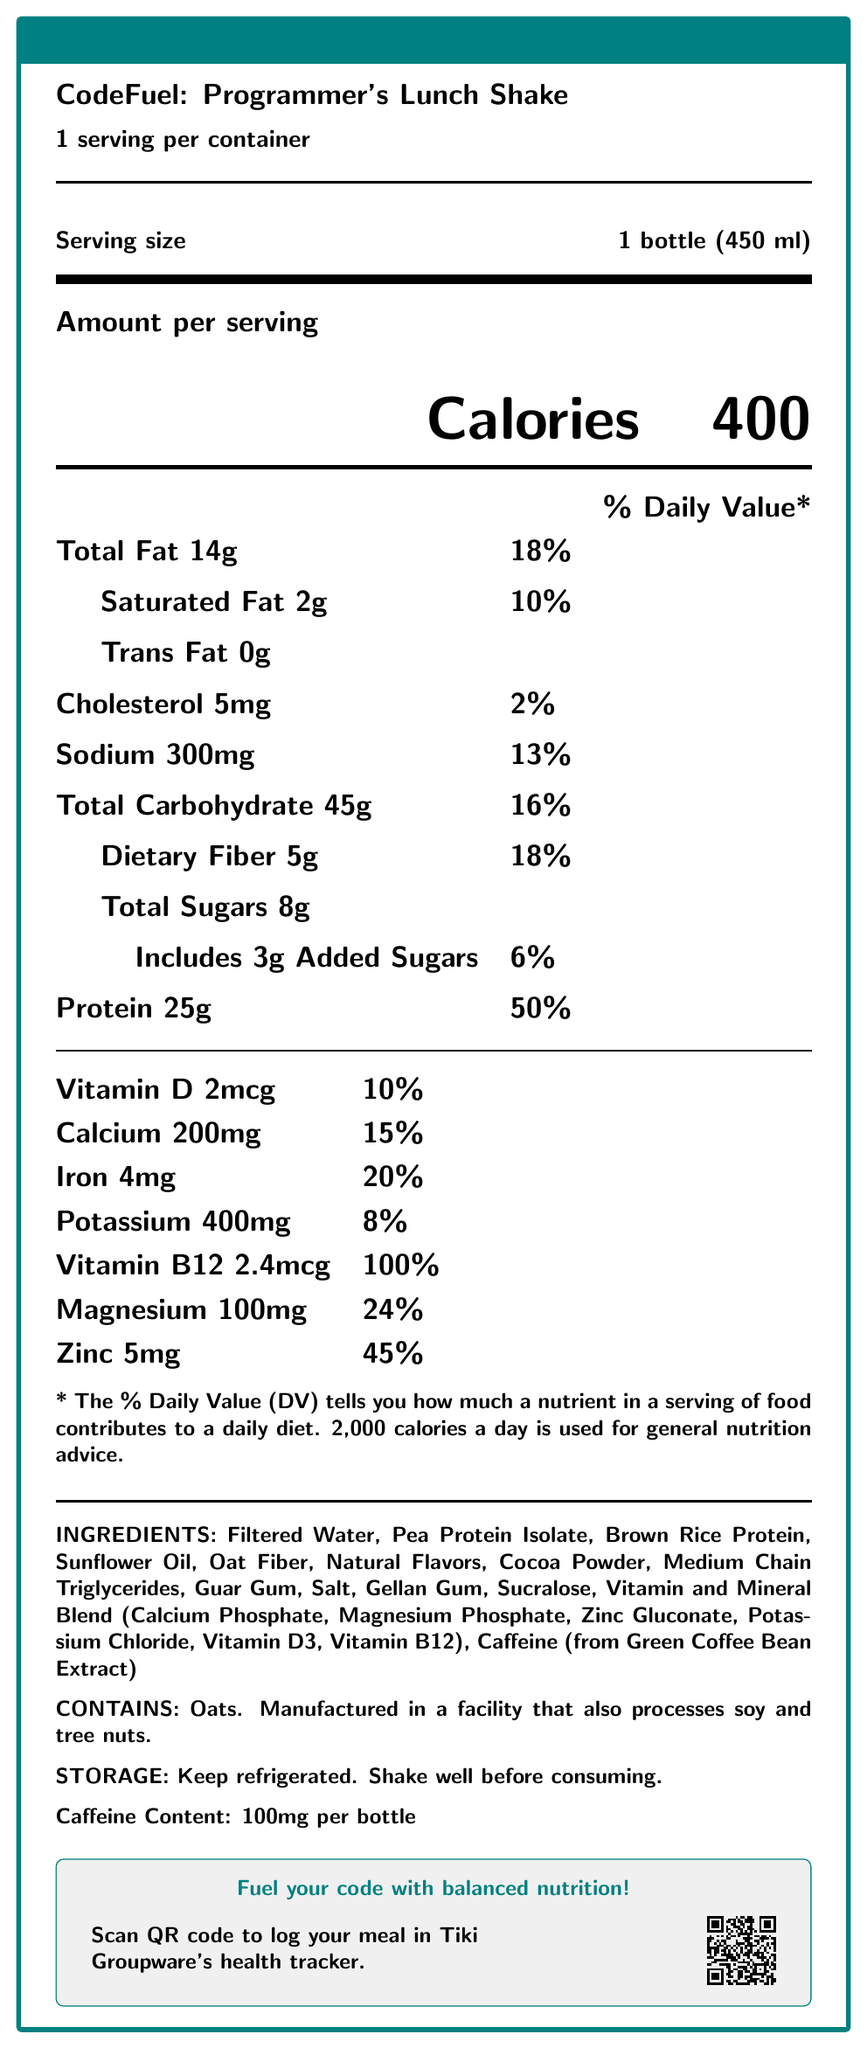what is the serving size for CodeFuel: Programmer's Lunch Shake? The document specifies the serving size as "1 bottle (450 ml)".
Answer: 1 bottle (450 ml) how many calories are in one serving of this shake? The document states that the shake has 400 calories per serving.
Answer: 400 what is the total amount of protein in this shake? The document mentions that the shake contains 25g of protein per serving.
Answer: 25g what are the primary sources of protein listed in the ingredients? The ingredients section lists "Pea Protein Isolate" and "Brown Rice Protein" as sources of protein.
Answer: Pea Protein Isolate, Brown Rice Protein how much caffeine does the shake contain? The document states the caffeine content is 100mg per bottle.
Answer: 100mg how much saturated fat is in one serving? The document indicates there are 2g of saturated fat per serving.
Answer: 2g which vitamin has the highest percent daily value in this shake? According to the document, Vitamin B12 has a daily value of 100%.
Answer: Vitamin B12 does this shake contain any trans fat? The document specifies that the shake contains 0g of trans fat.
Answer: No how much dietary fiber does the shake contain? The document specifies that the shake contains 5g of dietary fiber per serving.
Answer: 5g what allergens does the shake contain? The allergen information section states that the shake contains oats.
Answer: Oats which ingredient provides the caffeine content in the shake? A. Coffee B. Green Coffee Bean Extract C. Tea D. Cocoa Powder The ingredients list specifies "Caffeine (from Green Coffee Bean Extract)".
Answer: B. Green Coffee Bean Extract what is the calorie count for a typical daily diet used for general nutrition advice? A. 1,500 calories B. 2,000 calories C. 2,500 calories D. 3,000 calories The document mentions that 2,000 calories a day is used for general nutrition advice.
Answer: B. 2,000 calories Is there any added sugar in the shake? The document states that the shake includes 3g of added sugars.
Answer: Yes Can this shake be stored at room temperature before consuming? The storage information specifies "Keep refrigerated."
Answer: No summarize the main idea of the document. The document is structured to give a comprehensive overview of the nutritional profile of the shake, emphasizing its health benefits, ingredient composition, and how it integrates with a health tracking system.
Answer: The document provides nutritional information for "CodeFuel: Programmer's Lunch Shake", detailing its calories, macronutrients, vitamins, minerals, ingredients, allergens, caffeine content, and storage instructions. It also includes a tagline promoting balanced nutrition and mentions integration with Tiki Groupware. how much potassium is in this shake compared to the daily value percentage? The document states that the shake contains 400mg of potassium, which is 8% of the daily value.
Answer: 400mg, 8% how many total grams of fat does the shake contain? The shake contains a total of 14g of fat, as specified in the document.
Answer: 14g does the shake contain any tree nuts? The document states that it is manufactured in a facility that also processes tree nuts but does not specify if tree nuts were used directly in the shake.
Answer: Cannot be determined how many servings are in one container of the shake? The document specifies that there is 1 serving per container.
Answer: 1 